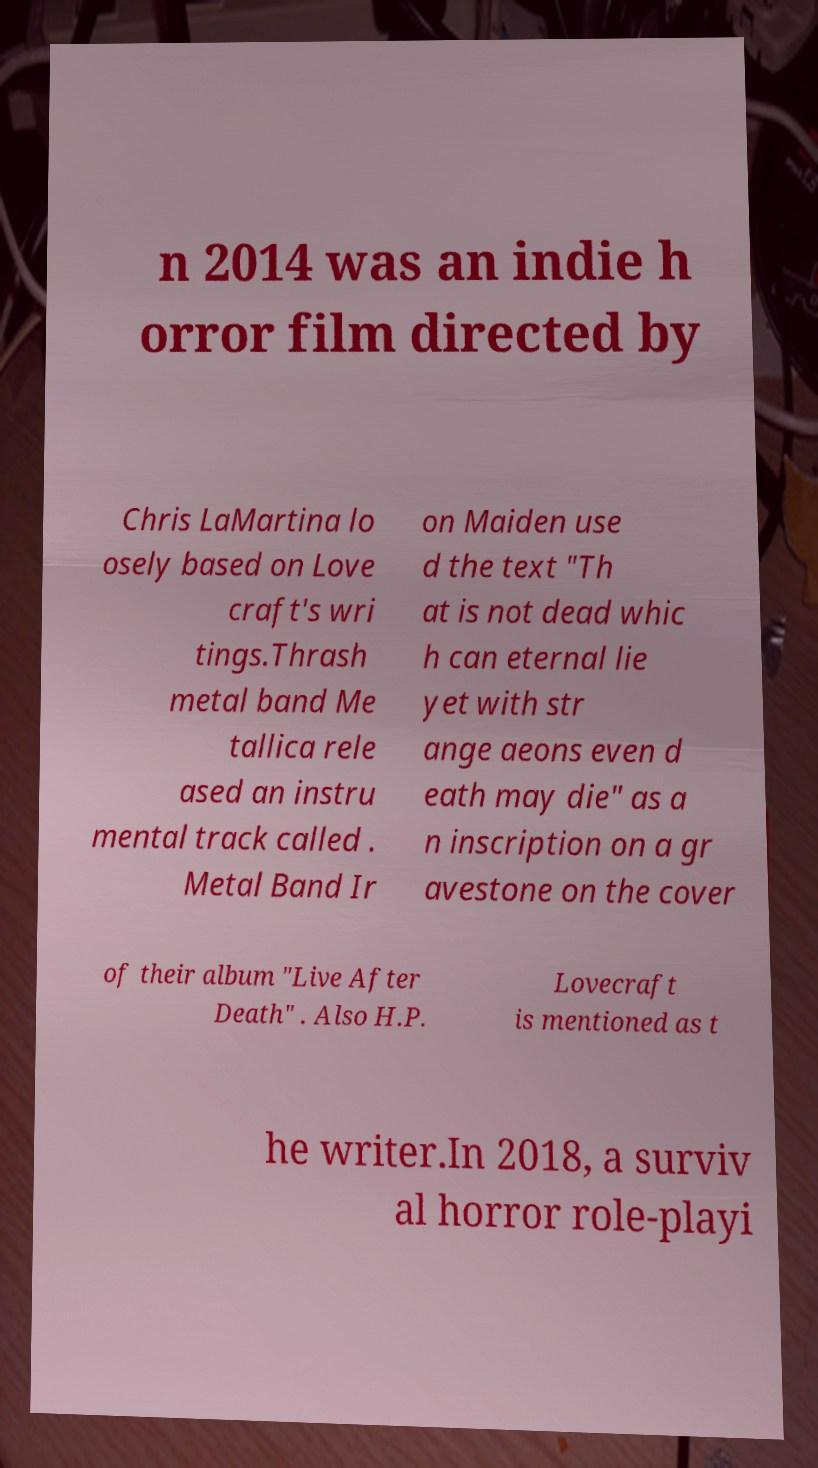Could you extract and type out the text from this image? n 2014 was an indie h orror film directed by Chris LaMartina lo osely based on Love craft's wri tings.Thrash metal band Me tallica rele ased an instru mental track called . Metal Band Ir on Maiden use d the text "Th at is not dead whic h can eternal lie yet with str ange aeons even d eath may die" as a n inscription on a gr avestone on the cover of their album "Live After Death" . Also H.P. Lovecraft is mentioned as t he writer.In 2018, a surviv al horror role-playi 